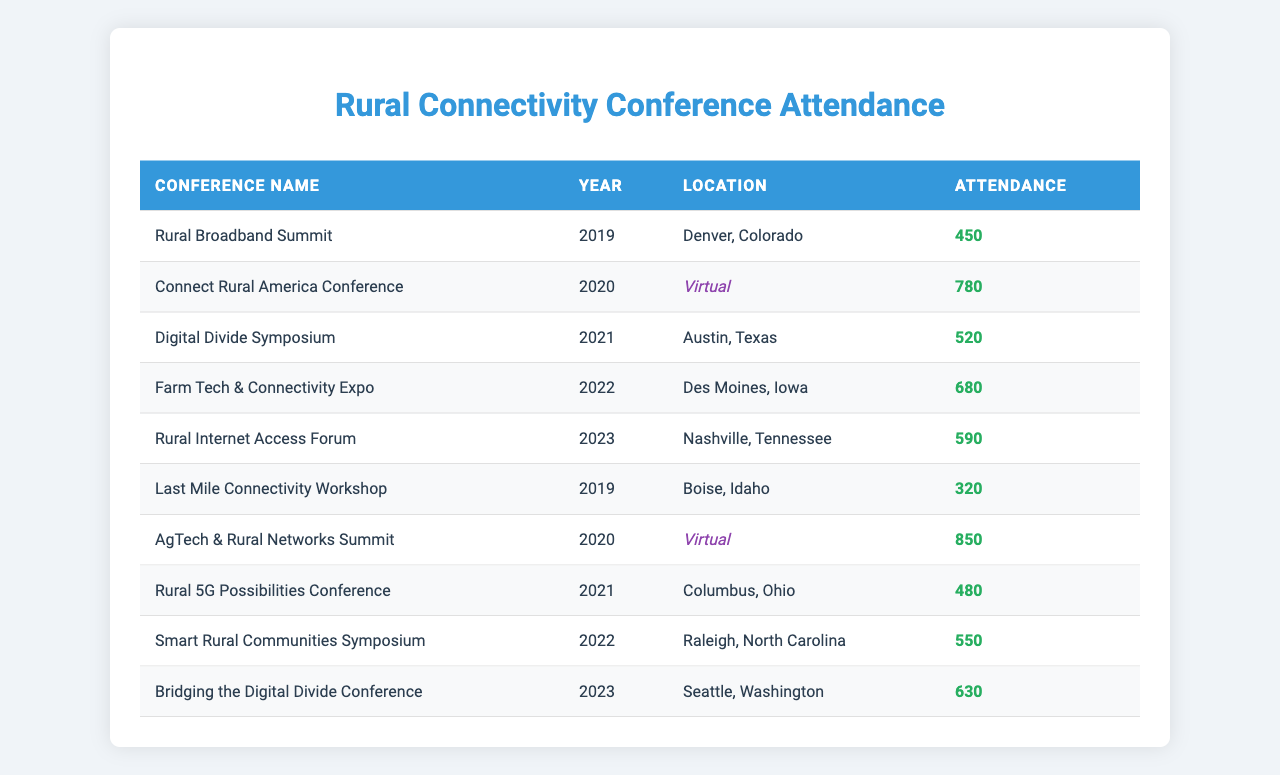What was the attendance at the Rural Broadband Summit in 2019? The table shows that the Rural Broadband Summit, held in 2019, had an attendance of 450 people.
Answer: 450 Which conference had the highest attendance and what was that number? The highest attendance was at the AgTech & Rural Networks Summit in 2020, with an attendance of 850.
Answer: 850 How many conferences had an attendance of over 600? By examining the table, the conferences with attendance over 600 are the AgTech & Rural Networks Summit (850), Connect Rural America Conference (780), and Farm Tech & Connectivity Expo (680), totaling 3 conferences.
Answer: 3 Was there any conference in 2021 that was held virtually? The table indicates that there were no conferences in 2021 that were held virtually; all 2021 conferences were geographically located.
Answer: No What is the total attendance of all conferences held in 2022? Summing the attendance for the two conferences in 2022: Farm Tech & Connectivity Expo (680) + Smart Rural Communities Symposium (550) = 1230, so the total attendance is 1230.
Answer: 1230 Between the years 2019 and 2023, which year had the lowest average attendance and what was that average? The attendance data shows the following years: 2019 (450 + 320 = 770, average = 385), 2020 (780 + 850 = 1630, average = 815), 2021 (520 + 480 = 1000, average = 500), 2022 (680 + 550 = 1230, average = 615), and 2023 (590 + 630 = 1220, average = 610). The lowest average attendance year is 2019 with 385.
Answer: 385 Which location had the lowest attendance, and how many attended? The table indicates that the Last Mile Connectivity Workshop in Boise, Idaho in 2019 had the lowest attendance with 320 people.
Answer: 320 How does the attendance of the Rural Internet Access Forum in 2023 compare to that of the Digital Divide Symposium in 2021? The attendance for the Rural Internet Access Forum in 2023 was 590 and for the Digital Divide Symposium in 2021 was 520. Thus, the Rural Internet Access Forum had 70 more attendees than the Digital Divide Symposium.
Answer: 70 more 